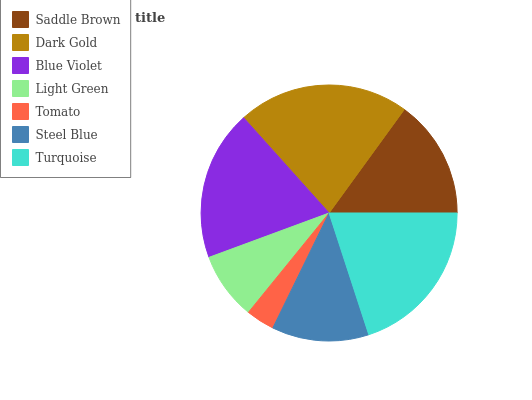Is Tomato the minimum?
Answer yes or no. Yes. Is Dark Gold the maximum?
Answer yes or no. Yes. Is Blue Violet the minimum?
Answer yes or no. No. Is Blue Violet the maximum?
Answer yes or no. No. Is Dark Gold greater than Blue Violet?
Answer yes or no. Yes. Is Blue Violet less than Dark Gold?
Answer yes or no. Yes. Is Blue Violet greater than Dark Gold?
Answer yes or no. No. Is Dark Gold less than Blue Violet?
Answer yes or no. No. Is Saddle Brown the high median?
Answer yes or no. Yes. Is Saddle Brown the low median?
Answer yes or no. Yes. Is Light Green the high median?
Answer yes or no. No. Is Tomato the low median?
Answer yes or no. No. 